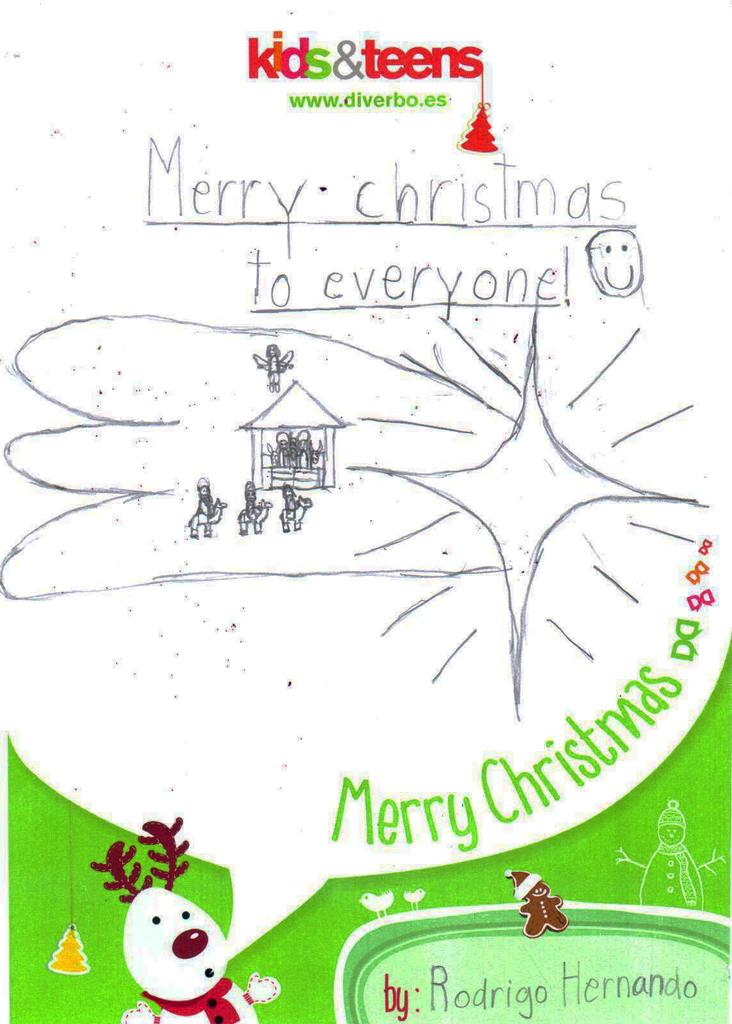What is the main object in the image? There is a greeting card in the image. What is depicted at the bottom of the greeting card? There is a cartoon at the bottom of the greeting card. What can be found on the greeting card besides the cartoon? There is text written on the greeting card. Can you tell me how many goats are playing basketball on the greeting card? There are no goats or basketball depicted on the greeting card; it features a cartoon and text. 